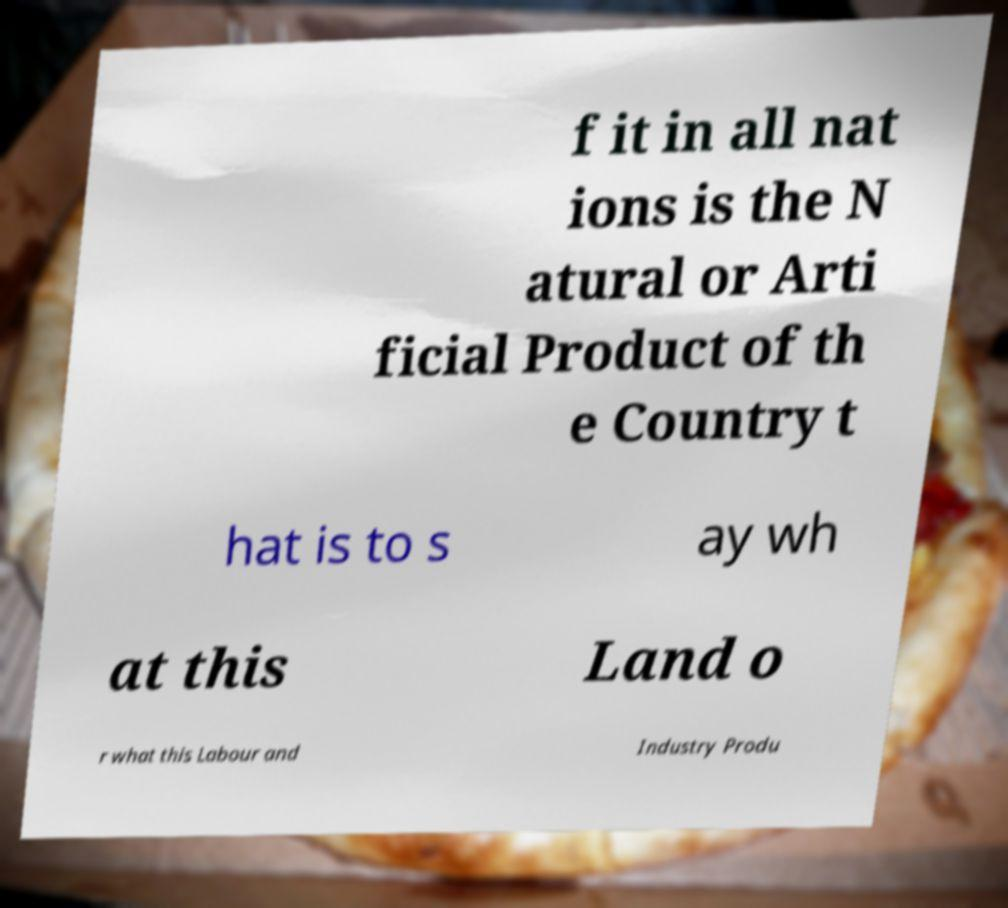There's text embedded in this image that I need extracted. Can you transcribe it verbatim? f it in all nat ions is the N atural or Arti ficial Product of th e Country t hat is to s ay wh at this Land o r what this Labour and Industry Produ 